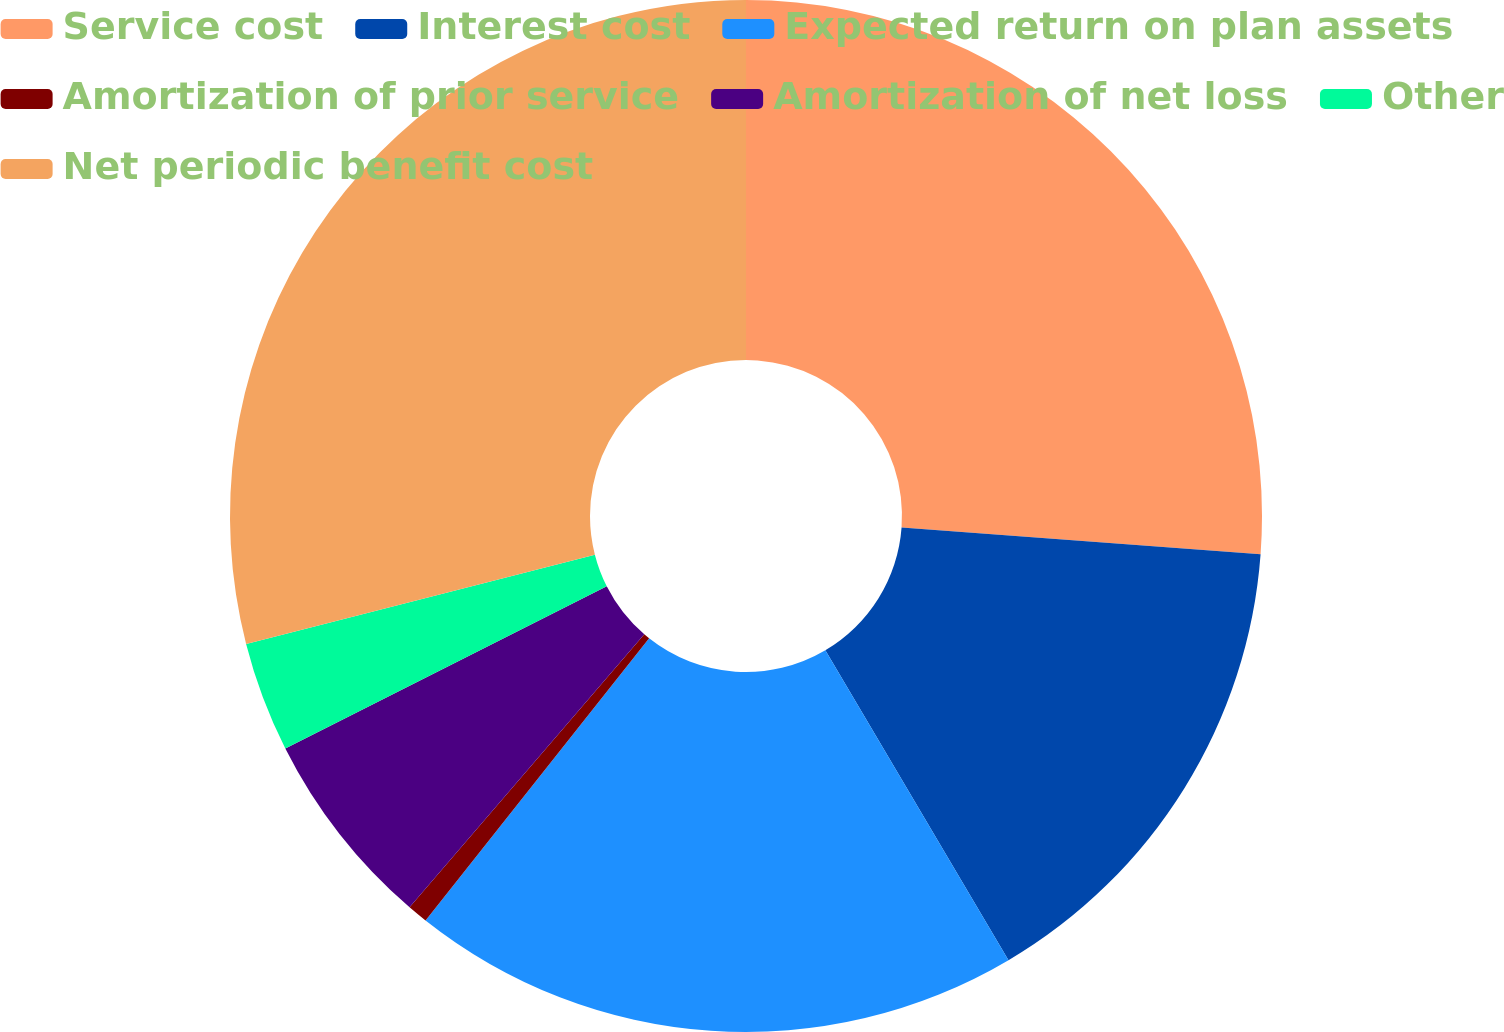Convert chart to OTSL. <chart><loc_0><loc_0><loc_500><loc_500><pie_chart><fcel>Service cost<fcel>Interest cost<fcel>Expected return on plan assets<fcel>Amortization of prior service<fcel>Amortization of net loss<fcel>Other<fcel>Net periodic benefit cost<nl><fcel>26.18%<fcel>15.33%<fcel>19.16%<fcel>0.64%<fcel>6.26%<fcel>3.45%<fcel>28.99%<nl></chart> 